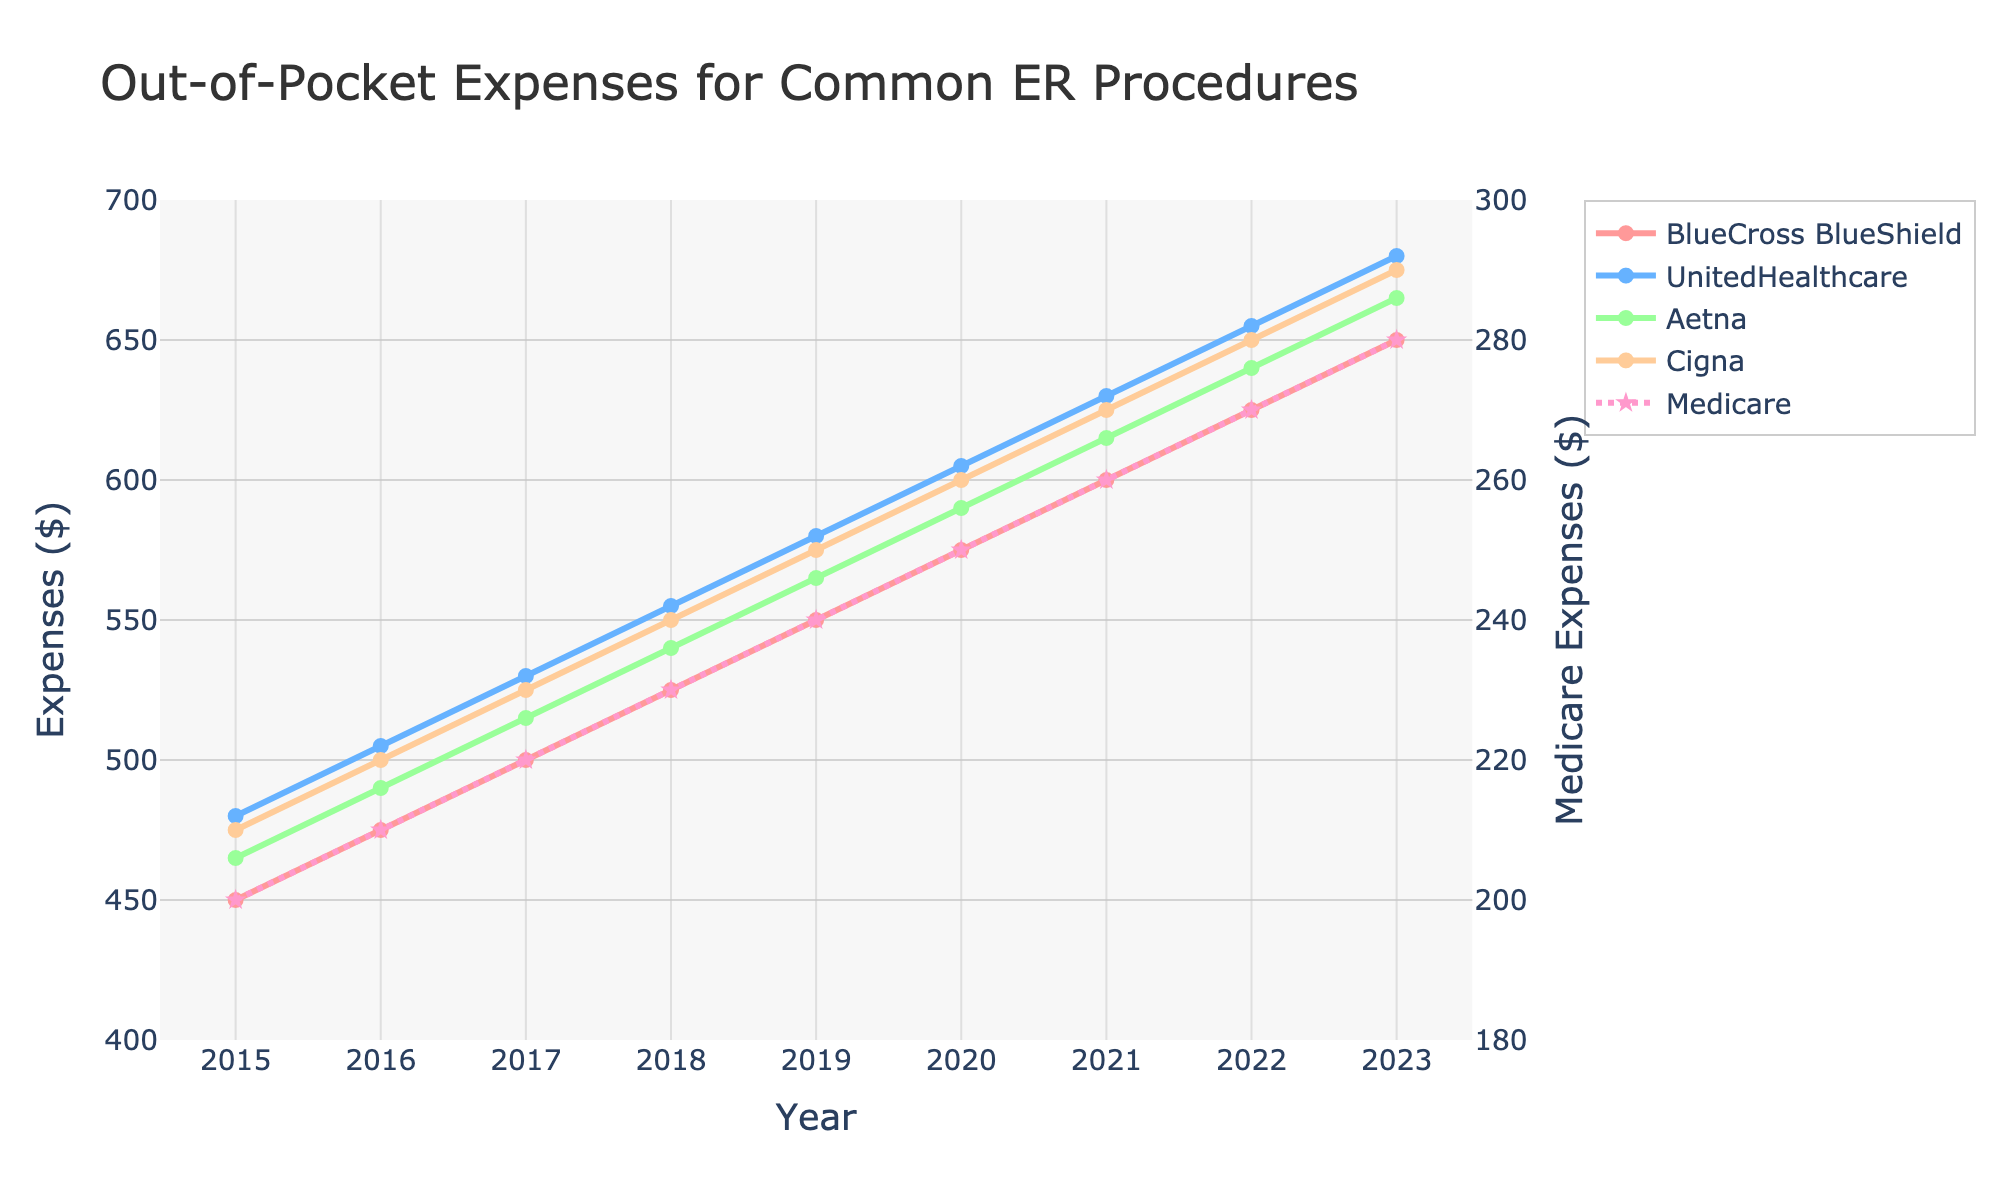What are the total out-of-pocket expenses for BlueCross BlueShield and Medicare in 2023? To find the total expenses, first identify the expenses for BlueCross BlueShield in 2023, which is $650, and the expenses for Medicare in 2023, which is $280. Add these two values together: $650 + $280 = $930.
Answer: $930 Which insurance provider saw the highest increase in out-of-pocket expenses from 2015 to 2023? Calculate the increase for each provider by subtracting the 2015 expense from the 2023 expense:
BlueCross BlueShield: $650 - $450 = $200
UnitedHealthcare: $680 - $480 = $200
Aetna: $665 - $465 = $200
Cigna: $675 - $475 = $200
Medicare: $280 - $200 = $80
All private providers saw the same highest increase of $200.
Answer: BlueCross BlueShield, UnitedHealthcare, Aetna, Cigna How does the increase in expenses for Medicare from 2015 to 2023 compare with that for Cigna? Subtract the 2015 expense from the 2023 expense for both Medicare and Cigna:
Medicare: $280 - $200 = $80
Cigna: $675 - $475 = $200
Compare the two increases: $80 (Medicare) is less than $200 (Cigna).
Answer: Medicare's increase is less Looking at the figure, which insurance provider had the most significant jump in expenses from 2021 to 2022? To determine this, calculate the difference in expenses between 2021 and 2022 for each provider:
BlueCross BlueShield: $625 - $600 = $25
UnitedHealthcare: $655 - $630 = $25
Aetna: $640 - $615 = $25
Cigna: $650 - $625 = $25
Medicare: $270 - $260 = $10
All private providers had the same increase of $25, which is the highest.
Answer: BlueCross BlueShield, UnitedHealthcare, Aetna, Cigna What was the out-of-pocket expense for Aetna in 2018, and how does it compare with the expense for Medicare in the same year? The expense for Aetna in 2018 was $540, and for Medicare, it was $230. The difference is $540 - $230 = $310. Aetna's expense is $310 higher than Medicare's.
Answer: Aetna's expense is $310 higher In what year did UnitedHealthcare's out-of-pocket expenses first exceed $600? Review UnitedHealthcare's expenses by year: $480 (2015), $505 (2016), $530 (2017), $555 (2018), $580 (2019), $605 (2020). The first year it exceeded $600 was 2020.
Answer: 2020 What is the average yearly out-of-pocket expense increase for Cigna from 2015 to 2023? Calculate the total increase from 2015 to 2023 for Cigna: $675 - $475 = $200. There are 8 years from 2015 to 2023. The average yearly increase is $200 / 8 = $25.
Answer: $25 Which provider has the least yearly variation in out-of-pocket expenses from 2015 to 2023? By observing the smoothness and consistency of the lines, Medicare shows the least variation with a gradual and steady increase compared to other providers with more fluctuating trends.
Answer: Medicare 